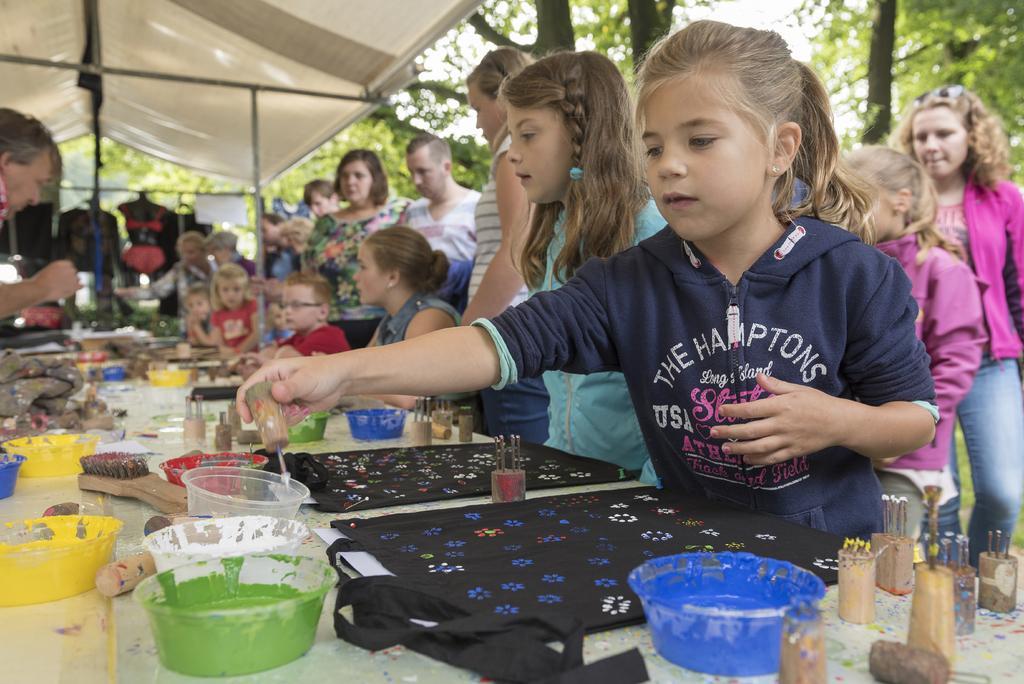Could you give a brief overview of what you see in this image? In this image we can see group of persons standing at the table. On the table bowls, glasses, clothes, colors, brush and some objects on the table. In the background there are trees, tent and sky. 